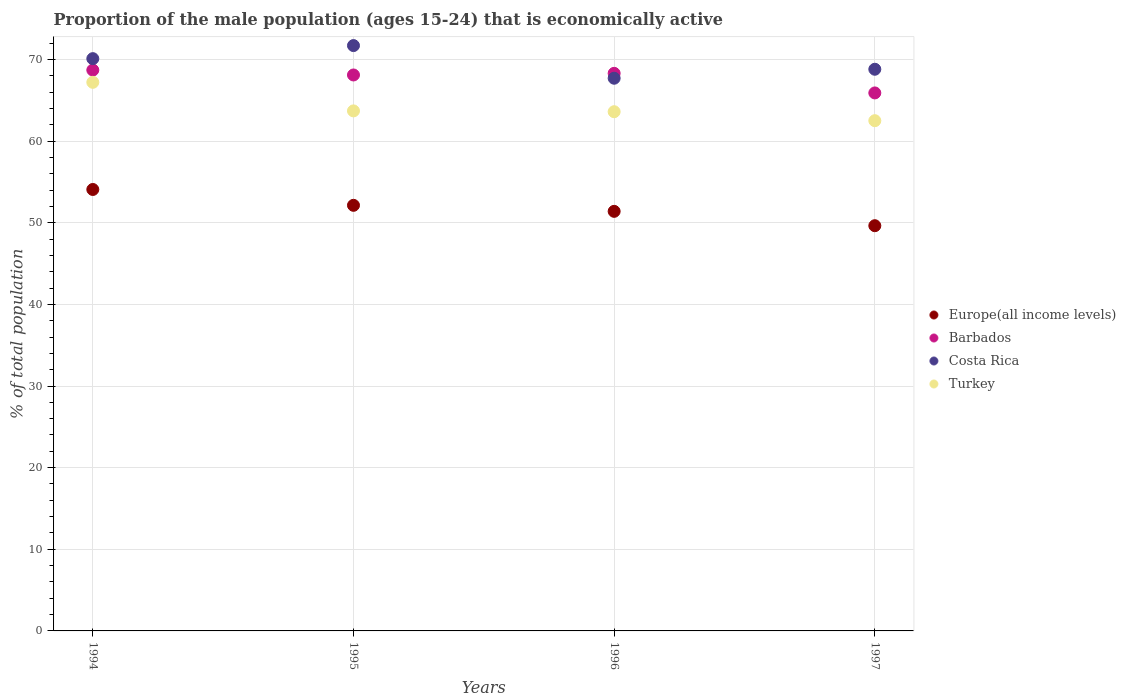How many different coloured dotlines are there?
Keep it short and to the point. 4. Is the number of dotlines equal to the number of legend labels?
Offer a very short reply. Yes. What is the proportion of the male population that is economically active in Barbados in 1995?
Provide a succinct answer. 68.1. Across all years, what is the maximum proportion of the male population that is economically active in Turkey?
Offer a very short reply. 67.2. Across all years, what is the minimum proportion of the male population that is economically active in Barbados?
Give a very brief answer. 65.9. What is the total proportion of the male population that is economically active in Costa Rica in the graph?
Your response must be concise. 278.3. What is the difference between the proportion of the male population that is economically active in Barbados in 1995 and that in 1997?
Offer a terse response. 2.2. What is the difference between the proportion of the male population that is economically active in Europe(all income levels) in 1997 and the proportion of the male population that is economically active in Barbados in 1996?
Offer a terse response. -18.66. What is the average proportion of the male population that is economically active in Turkey per year?
Make the answer very short. 64.25. What is the ratio of the proportion of the male population that is economically active in Costa Rica in 1996 to that in 1997?
Make the answer very short. 0.98. Is the proportion of the male population that is economically active in Europe(all income levels) in 1994 less than that in 1996?
Provide a short and direct response. No. Is the difference between the proportion of the male population that is economically active in Turkey in 1995 and 1996 greater than the difference between the proportion of the male population that is economically active in Barbados in 1995 and 1996?
Offer a terse response. Yes. What is the difference between the highest and the second highest proportion of the male population that is economically active in Europe(all income levels)?
Make the answer very short. 1.94. What is the difference between the highest and the lowest proportion of the male population that is economically active in Turkey?
Make the answer very short. 4.7. In how many years, is the proportion of the male population that is economically active in Costa Rica greater than the average proportion of the male population that is economically active in Costa Rica taken over all years?
Ensure brevity in your answer.  2. Is the sum of the proportion of the male population that is economically active in Costa Rica in 1994 and 1995 greater than the maximum proportion of the male population that is economically active in Turkey across all years?
Your answer should be very brief. Yes. Is it the case that in every year, the sum of the proportion of the male population that is economically active in Barbados and proportion of the male population that is economically active in Turkey  is greater than the sum of proportion of the male population that is economically active in Costa Rica and proportion of the male population that is economically active in Europe(all income levels)?
Your answer should be very brief. No. Does the proportion of the male population that is economically active in Costa Rica monotonically increase over the years?
Provide a short and direct response. No. Is the proportion of the male population that is economically active in Costa Rica strictly greater than the proportion of the male population that is economically active in Barbados over the years?
Keep it short and to the point. No. Is the proportion of the male population that is economically active in Turkey strictly less than the proportion of the male population that is economically active in Europe(all income levels) over the years?
Ensure brevity in your answer.  No. How many years are there in the graph?
Provide a short and direct response. 4. Are the values on the major ticks of Y-axis written in scientific E-notation?
Give a very brief answer. No. Where does the legend appear in the graph?
Ensure brevity in your answer.  Center right. What is the title of the graph?
Give a very brief answer. Proportion of the male population (ages 15-24) that is economically active. What is the label or title of the Y-axis?
Offer a terse response. % of total population. What is the % of total population in Europe(all income levels) in 1994?
Provide a succinct answer. 54.07. What is the % of total population in Barbados in 1994?
Provide a short and direct response. 68.7. What is the % of total population of Costa Rica in 1994?
Your response must be concise. 70.1. What is the % of total population of Turkey in 1994?
Provide a succinct answer. 67.2. What is the % of total population in Europe(all income levels) in 1995?
Make the answer very short. 52.13. What is the % of total population of Barbados in 1995?
Give a very brief answer. 68.1. What is the % of total population in Costa Rica in 1995?
Keep it short and to the point. 71.7. What is the % of total population in Turkey in 1995?
Offer a very short reply. 63.7. What is the % of total population in Europe(all income levels) in 1996?
Your response must be concise. 51.4. What is the % of total population in Barbados in 1996?
Keep it short and to the point. 68.3. What is the % of total population in Costa Rica in 1996?
Offer a terse response. 67.7. What is the % of total population of Turkey in 1996?
Your response must be concise. 63.6. What is the % of total population of Europe(all income levels) in 1997?
Your answer should be compact. 49.64. What is the % of total population in Barbados in 1997?
Your answer should be very brief. 65.9. What is the % of total population in Costa Rica in 1997?
Provide a succinct answer. 68.8. What is the % of total population of Turkey in 1997?
Provide a short and direct response. 62.5. Across all years, what is the maximum % of total population in Europe(all income levels)?
Provide a short and direct response. 54.07. Across all years, what is the maximum % of total population in Barbados?
Your answer should be very brief. 68.7. Across all years, what is the maximum % of total population of Costa Rica?
Your response must be concise. 71.7. Across all years, what is the maximum % of total population in Turkey?
Provide a short and direct response. 67.2. Across all years, what is the minimum % of total population in Europe(all income levels)?
Give a very brief answer. 49.64. Across all years, what is the minimum % of total population of Barbados?
Ensure brevity in your answer.  65.9. Across all years, what is the minimum % of total population in Costa Rica?
Your answer should be compact. 67.7. Across all years, what is the minimum % of total population in Turkey?
Offer a very short reply. 62.5. What is the total % of total population of Europe(all income levels) in the graph?
Keep it short and to the point. 207.24. What is the total % of total population of Barbados in the graph?
Your response must be concise. 271. What is the total % of total population of Costa Rica in the graph?
Your answer should be very brief. 278.3. What is the total % of total population of Turkey in the graph?
Your answer should be compact. 257. What is the difference between the % of total population in Europe(all income levels) in 1994 and that in 1995?
Your response must be concise. 1.94. What is the difference between the % of total population of Europe(all income levels) in 1994 and that in 1996?
Ensure brevity in your answer.  2.68. What is the difference between the % of total population in Barbados in 1994 and that in 1996?
Offer a very short reply. 0.4. What is the difference between the % of total population in Turkey in 1994 and that in 1996?
Offer a very short reply. 3.6. What is the difference between the % of total population of Europe(all income levels) in 1994 and that in 1997?
Keep it short and to the point. 4.44. What is the difference between the % of total population of Barbados in 1994 and that in 1997?
Your answer should be very brief. 2.8. What is the difference between the % of total population of Europe(all income levels) in 1995 and that in 1996?
Ensure brevity in your answer.  0.74. What is the difference between the % of total population of Turkey in 1995 and that in 1996?
Your answer should be very brief. 0.1. What is the difference between the % of total population in Europe(all income levels) in 1995 and that in 1997?
Keep it short and to the point. 2.5. What is the difference between the % of total population in Turkey in 1995 and that in 1997?
Offer a terse response. 1.2. What is the difference between the % of total population in Europe(all income levels) in 1996 and that in 1997?
Offer a very short reply. 1.76. What is the difference between the % of total population in Barbados in 1996 and that in 1997?
Offer a very short reply. 2.4. What is the difference between the % of total population in Europe(all income levels) in 1994 and the % of total population in Barbados in 1995?
Provide a succinct answer. -14.03. What is the difference between the % of total population in Europe(all income levels) in 1994 and the % of total population in Costa Rica in 1995?
Your answer should be very brief. -17.63. What is the difference between the % of total population in Europe(all income levels) in 1994 and the % of total population in Turkey in 1995?
Offer a very short reply. -9.63. What is the difference between the % of total population in Barbados in 1994 and the % of total population in Turkey in 1995?
Give a very brief answer. 5. What is the difference between the % of total population in Europe(all income levels) in 1994 and the % of total population in Barbados in 1996?
Keep it short and to the point. -14.23. What is the difference between the % of total population of Europe(all income levels) in 1994 and the % of total population of Costa Rica in 1996?
Give a very brief answer. -13.63. What is the difference between the % of total population in Europe(all income levels) in 1994 and the % of total population in Turkey in 1996?
Provide a succinct answer. -9.53. What is the difference between the % of total population in Barbados in 1994 and the % of total population in Costa Rica in 1996?
Give a very brief answer. 1. What is the difference between the % of total population of Barbados in 1994 and the % of total population of Turkey in 1996?
Keep it short and to the point. 5.1. What is the difference between the % of total population of Europe(all income levels) in 1994 and the % of total population of Barbados in 1997?
Provide a succinct answer. -11.83. What is the difference between the % of total population of Europe(all income levels) in 1994 and the % of total population of Costa Rica in 1997?
Keep it short and to the point. -14.73. What is the difference between the % of total population of Europe(all income levels) in 1994 and the % of total population of Turkey in 1997?
Your answer should be compact. -8.43. What is the difference between the % of total population in Costa Rica in 1994 and the % of total population in Turkey in 1997?
Your answer should be very brief. 7.6. What is the difference between the % of total population in Europe(all income levels) in 1995 and the % of total population in Barbados in 1996?
Provide a succinct answer. -16.17. What is the difference between the % of total population in Europe(all income levels) in 1995 and the % of total population in Costa Rica in 1996?
Offer a terse response. -15.57. What is the difference between the % of total population in Europe(all income levels) in 1995 and the % of total population in Turkey in 1996?
Your answer should be compact. -11.47. What is the difference between the % of total population of Barbados in 1995 and the % of total population of Costa Rica in 1996?
Give a very brief answer. 0.4. What is the difference between the % of total population in Barbados in 1995 and the % of total population in Turkey in 1996?
Provide a short and direct response. 4.5. What is the difference between the % of total population in Europe(all income levels) in 1995 and the % of total population in Barbados in 1997?
Give a very brief answer. -13.77. What is the difference between the % of total population in Europe(all income levels) in 1995 and the % of total population in Costa Rica in 1997?
Your answer should be very brief. -16.67. What is the difference between the % of total population in Europe(all income levels) in 1995 and the % of total population in Turkey in 1997?
Offer a very short reply. -10.37. What is the difference between the % of total population of Barbados in 1995 and the % of total population of Turkey in 1997?
Provide a short and direct response. 5.6. What is the difference between the % of total population in Europe(all income levels) in 1996 and the % of total population in Barbados in 1997?
Keep it short and to the point. -14.5. What is the difference between the % of total population of Europe(all income levels) in 1996 and the % of total population of Costa Rica in 1997?
Your response must be concise. -17.4. What is the difference between the % of total population in Europe(all income levels) in 1996 and the % of total population in Turkey in 1997?
Ensure brevity in your answer.  -11.1. What is the average % of total population in Europe(all income levels) per year?
Your response must be concise. 51.81. What is the average % of total population of Barbados per year?
Your answer should be compact. 67.75. What is the average % of total population of Costa Rica per year?
Ensure brevity in your answer.  69.58. What is the average % of total population in Turkey per year?
Make the answer very short. 64.25. In the year 1994, what is the difference between the % of total population in Europe(all income levels) and % of total population in Barbados?
Provide a short and direct response. -14.63. In the year 1994, what is the difference between the % of total population in Europe(all income levels) and % of total population in Costa Rica?
Your answer should be compact. -16.03. In the year 1994, what is the difference between the % of total population of Europe(all income levels) and % of total population of Turkey?
Give a very brief answer. -13.13. In the year 1994, what is the difference between the % of total population in Barbados and % of total population in Turkey?
Give a very brief answer. 1.5. In the year 1995, what is the difference between the % of total population of Europe(all income levels) and % of total population of Barbados?
Your answer should be very brief. -15.97. In the year 1995, what is the difference between the % of total population of Europe(all income levels) and % of total population of Costa Rica?
Offer a terse response. -19.57. In the year 1995, what is the difference between the % of total population in Europe(all income levels) and % of total population in Turkey?
Your response must be concise. -11.57. In the year 1995, what is the difference between the % of total population of Barbados and % of total population of Turkey?
Provide a succinct answer. 4.4. In the year 1996, what is the difference between the % of total population of Europe(all income levels) and % of total population of Barbados?
Give a very brief answer. -16.9. In the year 1996, what is the difference between the % of total population in Europe(all income levels) and % of total population in Costa Rica?
Give a very brief answer. -16.3. In the year 1996, what is the difference between the % of total population of Europe(all income levels) and % of total population of Turkey?
Give a very brief answer. -12.2. In the year 1996, what is the difference between the % of total population of Barbados and % of total population of Costa Rica?
Provide a succinct answer. 0.6. In the year 1996, what is the difference between the % of total population in Barbados and % of total population in Turkey?
Make the answer very short. 4.7. In the year 1997, what is the difference between the % of total population in Europe(all income levels) and % of total population in Barbados?
Ensure brevity in your answer.  -16.26. In the year 1997, what is the difference between the % of total population in Europe(all income levels) and % of total population in Costa Rica?
Offer a terse response. -19.16. In the year 1997, what is the difference between the % of total population of Europe(all income levels) and % of total population of Turkey?
Offer a terse response. -12.86. What is the ratio of the % of total population in Europe(all income levels) in 1994 to that in 1995?
Give a very brief answer. 1.04. What is the ratio of the % of total population in Barbados in 1994 to that in 1995?
Offer a very short reply. 1.01. What is the ratio of the % of total population of Costa Rica in 1994 to that in 1995?
Your response must be concise. 0.98. What is the ratio of the % of total population in Turkey in 1994 to that in 1995?
Provide a succinct answer. 1.05. What is the ratio of the % of total population of Europe(all income levels) in 1994 to that in 1996?
Give a very brief answer. 1.05. What is the ratio of the % of total population of Barbados in 1994 to that in 1996?
Ensure brevity in your answer.  1.01. What is the ratio of the % of total population of Costa Rica in 1994 to that in 1996?
Ensure brevity in your answer.  1.04. What is the ratio of the % of total population of Turkey in 1994 to that in 1996?
Keep it short and to the point. 1.06. What is the ratio of the % of total population of Europe(all income levels) in 1994 to that in 1997?
Ensure brevity in your answer.  1.09. What is the ratio of the % of total population of Barbados in 1994 to that in 1997?
Offer a terse response. 1.04. What is the ratio of the % of total population of Costa Rica in 1994 to that in 1997?
Provide a succinct answer. 1.02. What is the ratio of the % of total population of Turkey in 1994 to that in 1997?
Ensure brevity in your answer.  1.08. What is the ratio of the % of total population of Europe(all income levels) in 1995 to that in 1996?
Give a very brief answer. 1.01. What is the ratio of the % of total population in Barbados in 1995 to that in 1996?
Your answer should be very brief. 1. What is the ratio of the % of total population in Costa Rica in 1995 to that in 1996?
Your answer should be very brief. 1.06. What is the ratio of the % of total population of Europe(all income levels) in 1995 to that in 1997?
Provide a succinct answer. 1.05. What is the ratio of the % of total population of Barbados in 1995 to that in 1997?
Provide a short and direct response. 1.03. What is the ratio of the % of total population of Costa Rica in 1995 to that in 1997?
Make the answer very short. 1.04. What is the ratio of the % of total population of Turkey in 1995 to that in 1997?
Offer a very short reply. 1.02. What is the ratio of the % of total population in Europe(all income levels) in 1996 to that in 1997?
Your answer should be very brief. 1.04. What is the ratio of the % of total population in Barbados in 1996 to that in 1997?
Provide a succinct answer. 1.04. What is the ratio of the % of total population of Turkey in 1996 to that in 1997?
Provide a succinct answer. 1.02. What is the difference between the highest and the second highest % of total population of Europe(all income levels)?
Ensure brevity in your answer.  1.94. What is the difference between the highest and the second highest % of total population in Barbados?
Offer a very short reply. 0.4. What is the difference between the highest and the second highest % of total population of Costa Rica?
Your answer should be very brief. 1.6. What is the difference between the highest and the second highest % of total population in Turkey?
Ensure brevity in your answer.  3.5. What is the difference between the highest and the lowest % of total population in Europe(all income levels)?
Your answer should be compact. 4.44. What is the difference between the highest and the lowest % of total population of Barbados?
Your answer should be very brief. 2.8. What is the difference between the highest and the lowest % of total population of Costa Rica?
Your answer should be very brief. 4. What is the difference between the highest and the lowest % of total population of Turkey?
Your response must be concise. 4.7. 